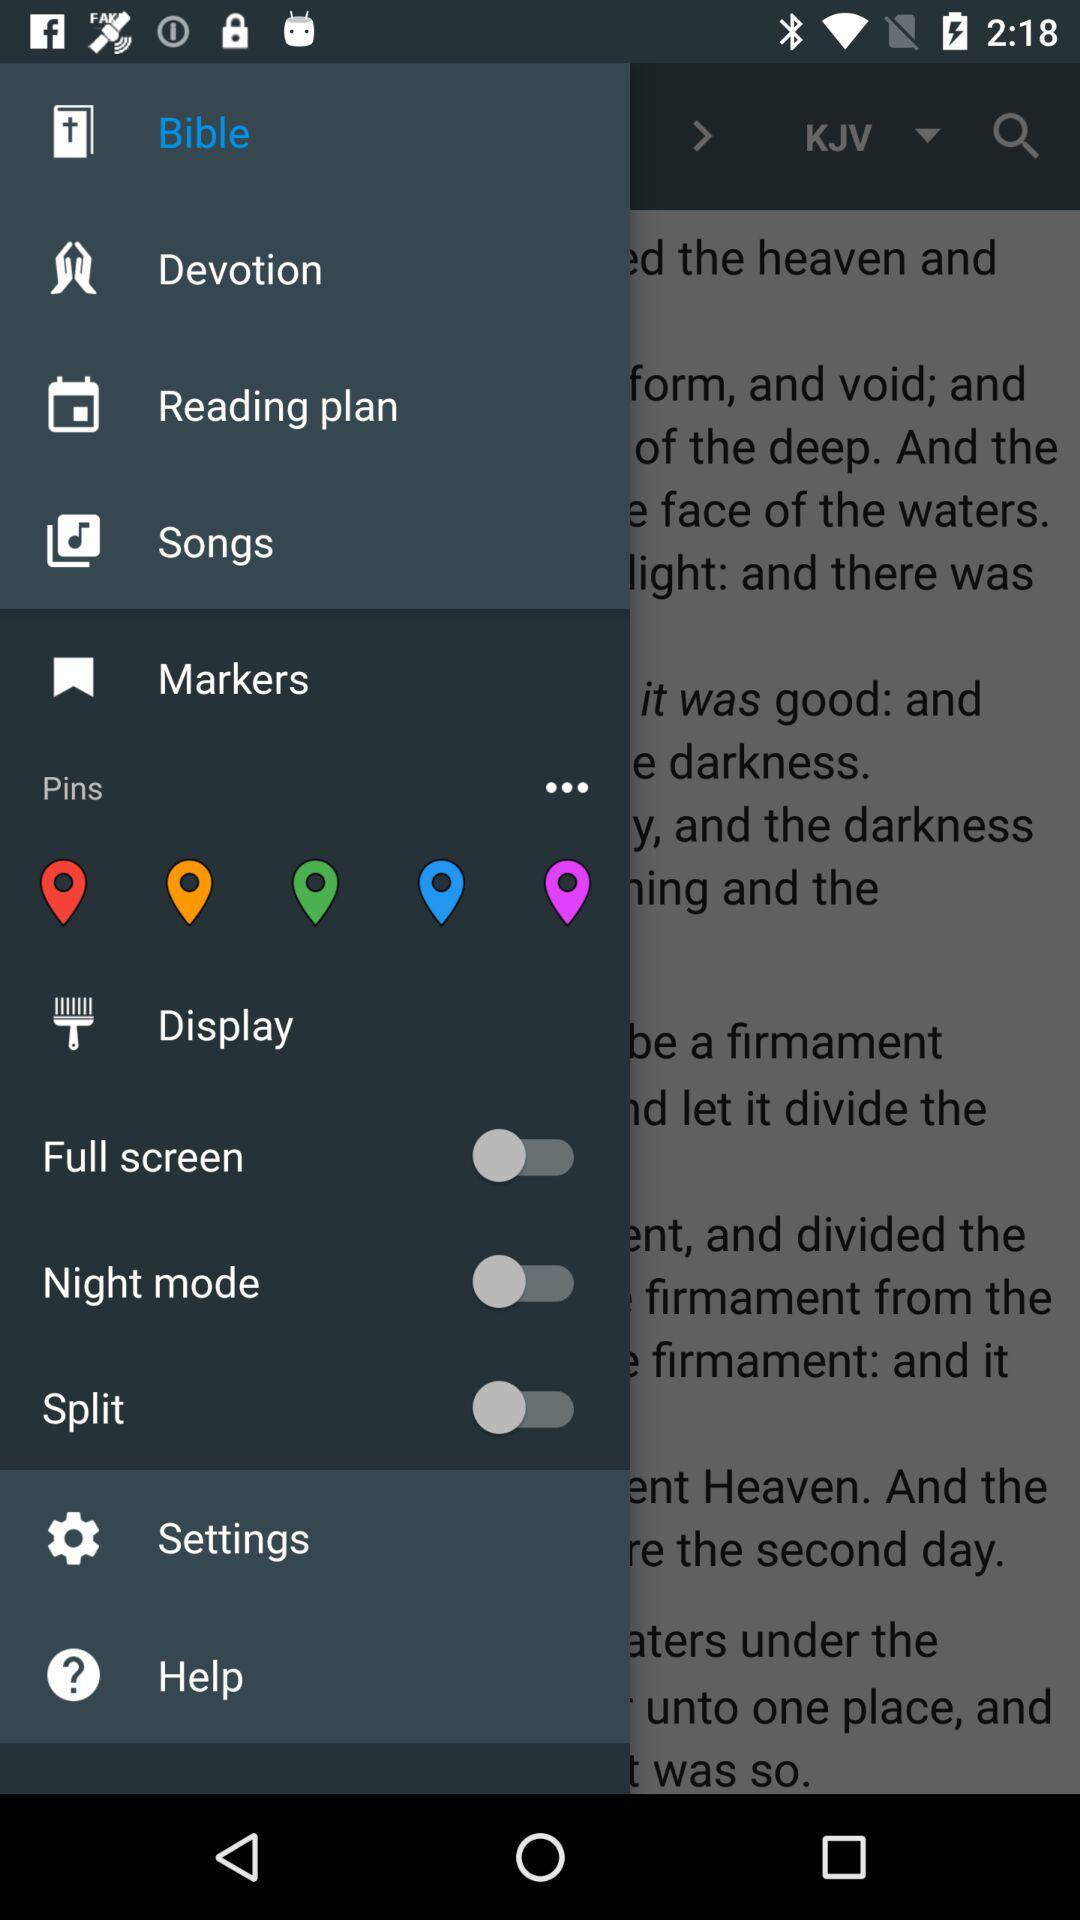What's the selected item in the menu? The selected item in the menu is "Bible". 